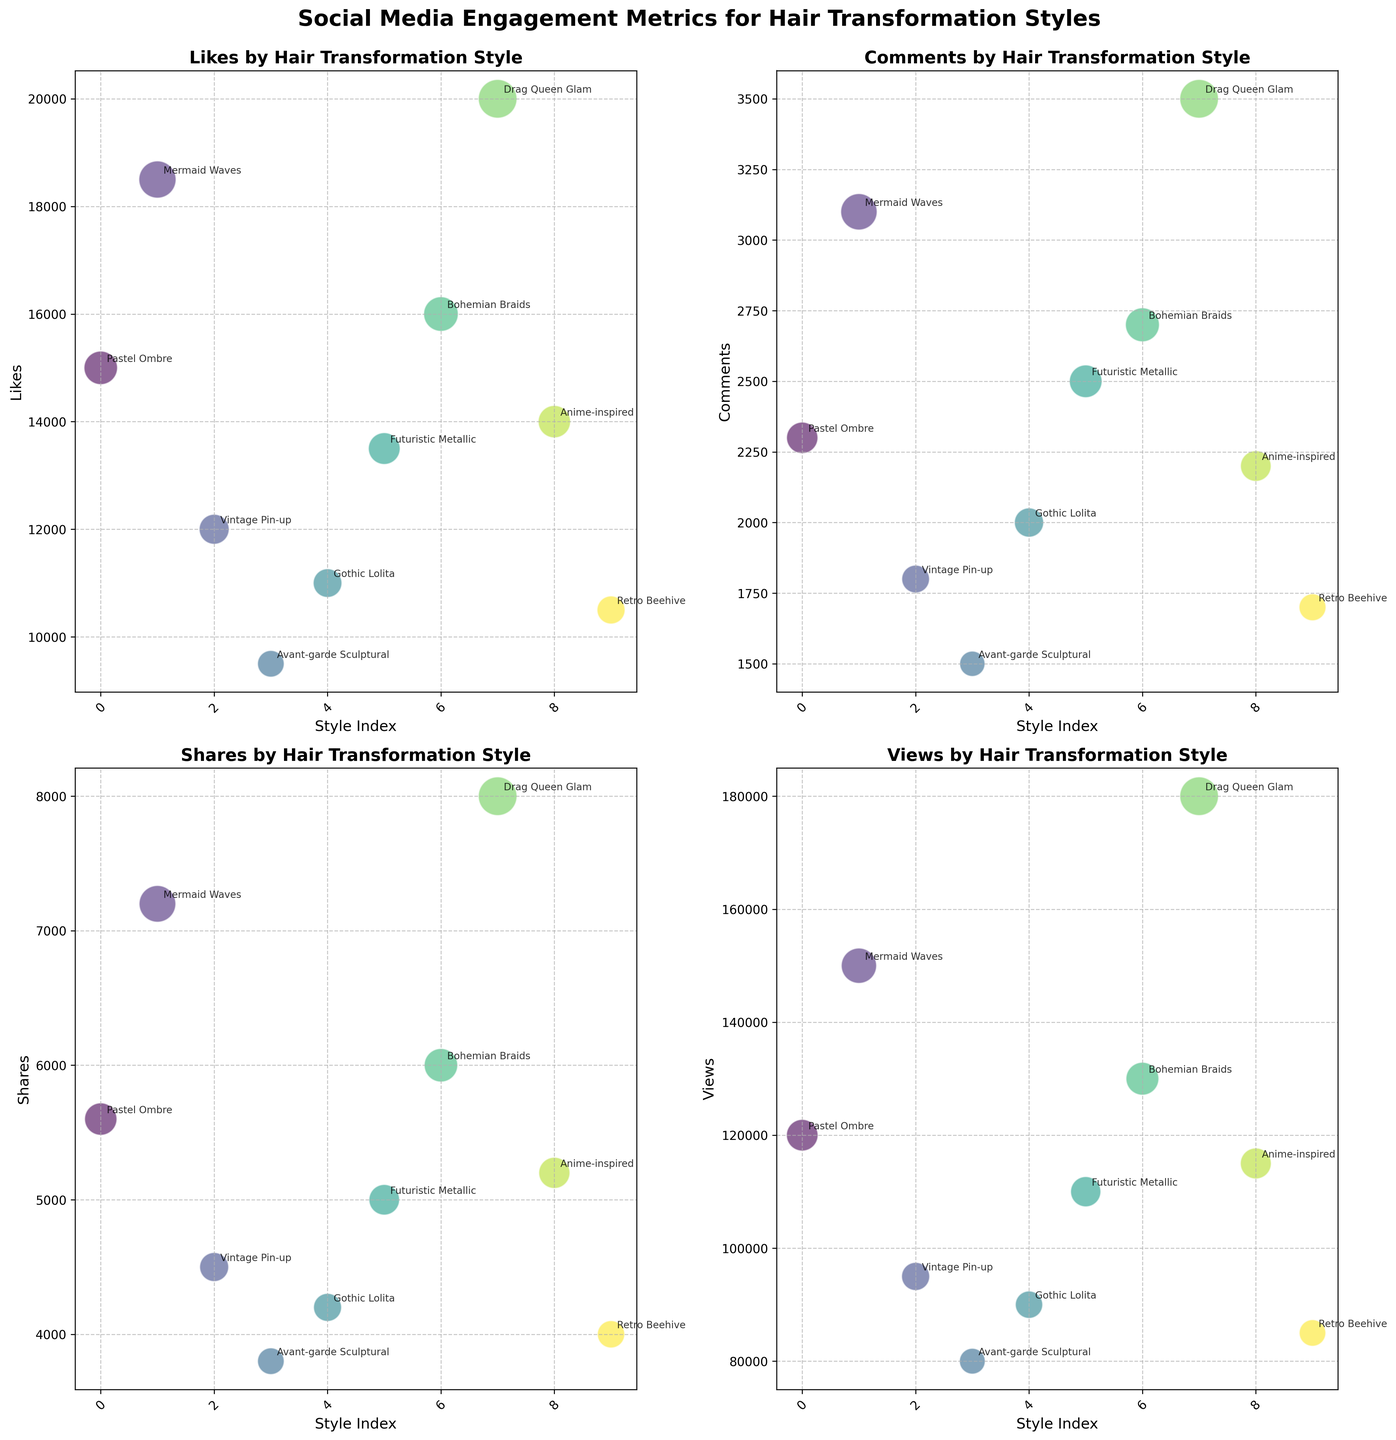What is the title of the figure? The title of the figure is usually positioned at the top and is meant to summarize the content of the plot. Here, it reads "Social Media Engagement Metrics for Hair Transformation Styles."
Answer: Social Media Engagement Metrics for Hair Transformation Styles Which style has the highest number of Likes? Check the bubble plot under 'Likes' and see which bubble is the largest, indicating the greatest number of Likes. The largest bubble is for "Drag Queen Glam."
Answer: Drag Queen Glam How many styles have more than 2000 Comments? Look at the 'Comments' subplot and count the number of bubbles with a comment value greater than 2000. These are "Mermaid Waves," "Bohemian Braids," "Drag Queen Glam," and "Futuristic Metallic."
Answer: 4 Which style has fewer Shares: Gothic Lolita or Futuristic Metallic? In the 'Shares' subplot, locate the bubbles for Gothic Lolita and Futuristic Metallic and compare their sizes or exact values. Gothic Lolita has fewer Shares.
Answer: Gothic Lolita What is the index range displayed on the x-axis for each subplot? Each subplot has an identical x-axis range, representing the index for each style. The range should be from 0 to the length of the DataFrame minus one. Since there are 10 styles, the range is from 0 to 9.
Answer: 0 to 9 Calculate the average number of views across all styles. To find the average, sum the number of views for all styles and divide by the number of styles. The sum is 120000 + 150000 + 95000 + 80000 + 90000 + 110000 + 130000 + 180000 + 115000 + 85000 = 1150000. Dividing by 10 gives an average of 115000.
Answer: 115000 Which subplot shows the highest dispersion in data points? Dispersion is the spread of data points. By observing visually, the 'Views' subplot has the widest range between its bubbles, from 80000 to 180000 views.
Answer: Views Compare the number of Likes for Vintage Pin-up and Mermaid Waves. In the 'Likes' subplot, check the values for Vintage Pin-up (12000) and Mermaid Waves (18500), and compare them. Mermaid Waves has more Likes than Vintage Pin-up.
Answer: Mermaid Waves Is there any style that has the highest metric value in more than one subplot? Observe the highest points in each subplot, focusing especially on the largest bubbles. "Drag Queen Glam" has the highest values in both 'Likes' and 'Views.'
Answer: Drag Queen Glam Which bubble color represents the Anime-inspired style? Each style is represented by a unique color consistent across all subplots. Find the color associated with Anime-inspired in any subplot, and it stays the same across all. It's a shade from the viridis colormap.
Answer: A shade from viridis colormap 